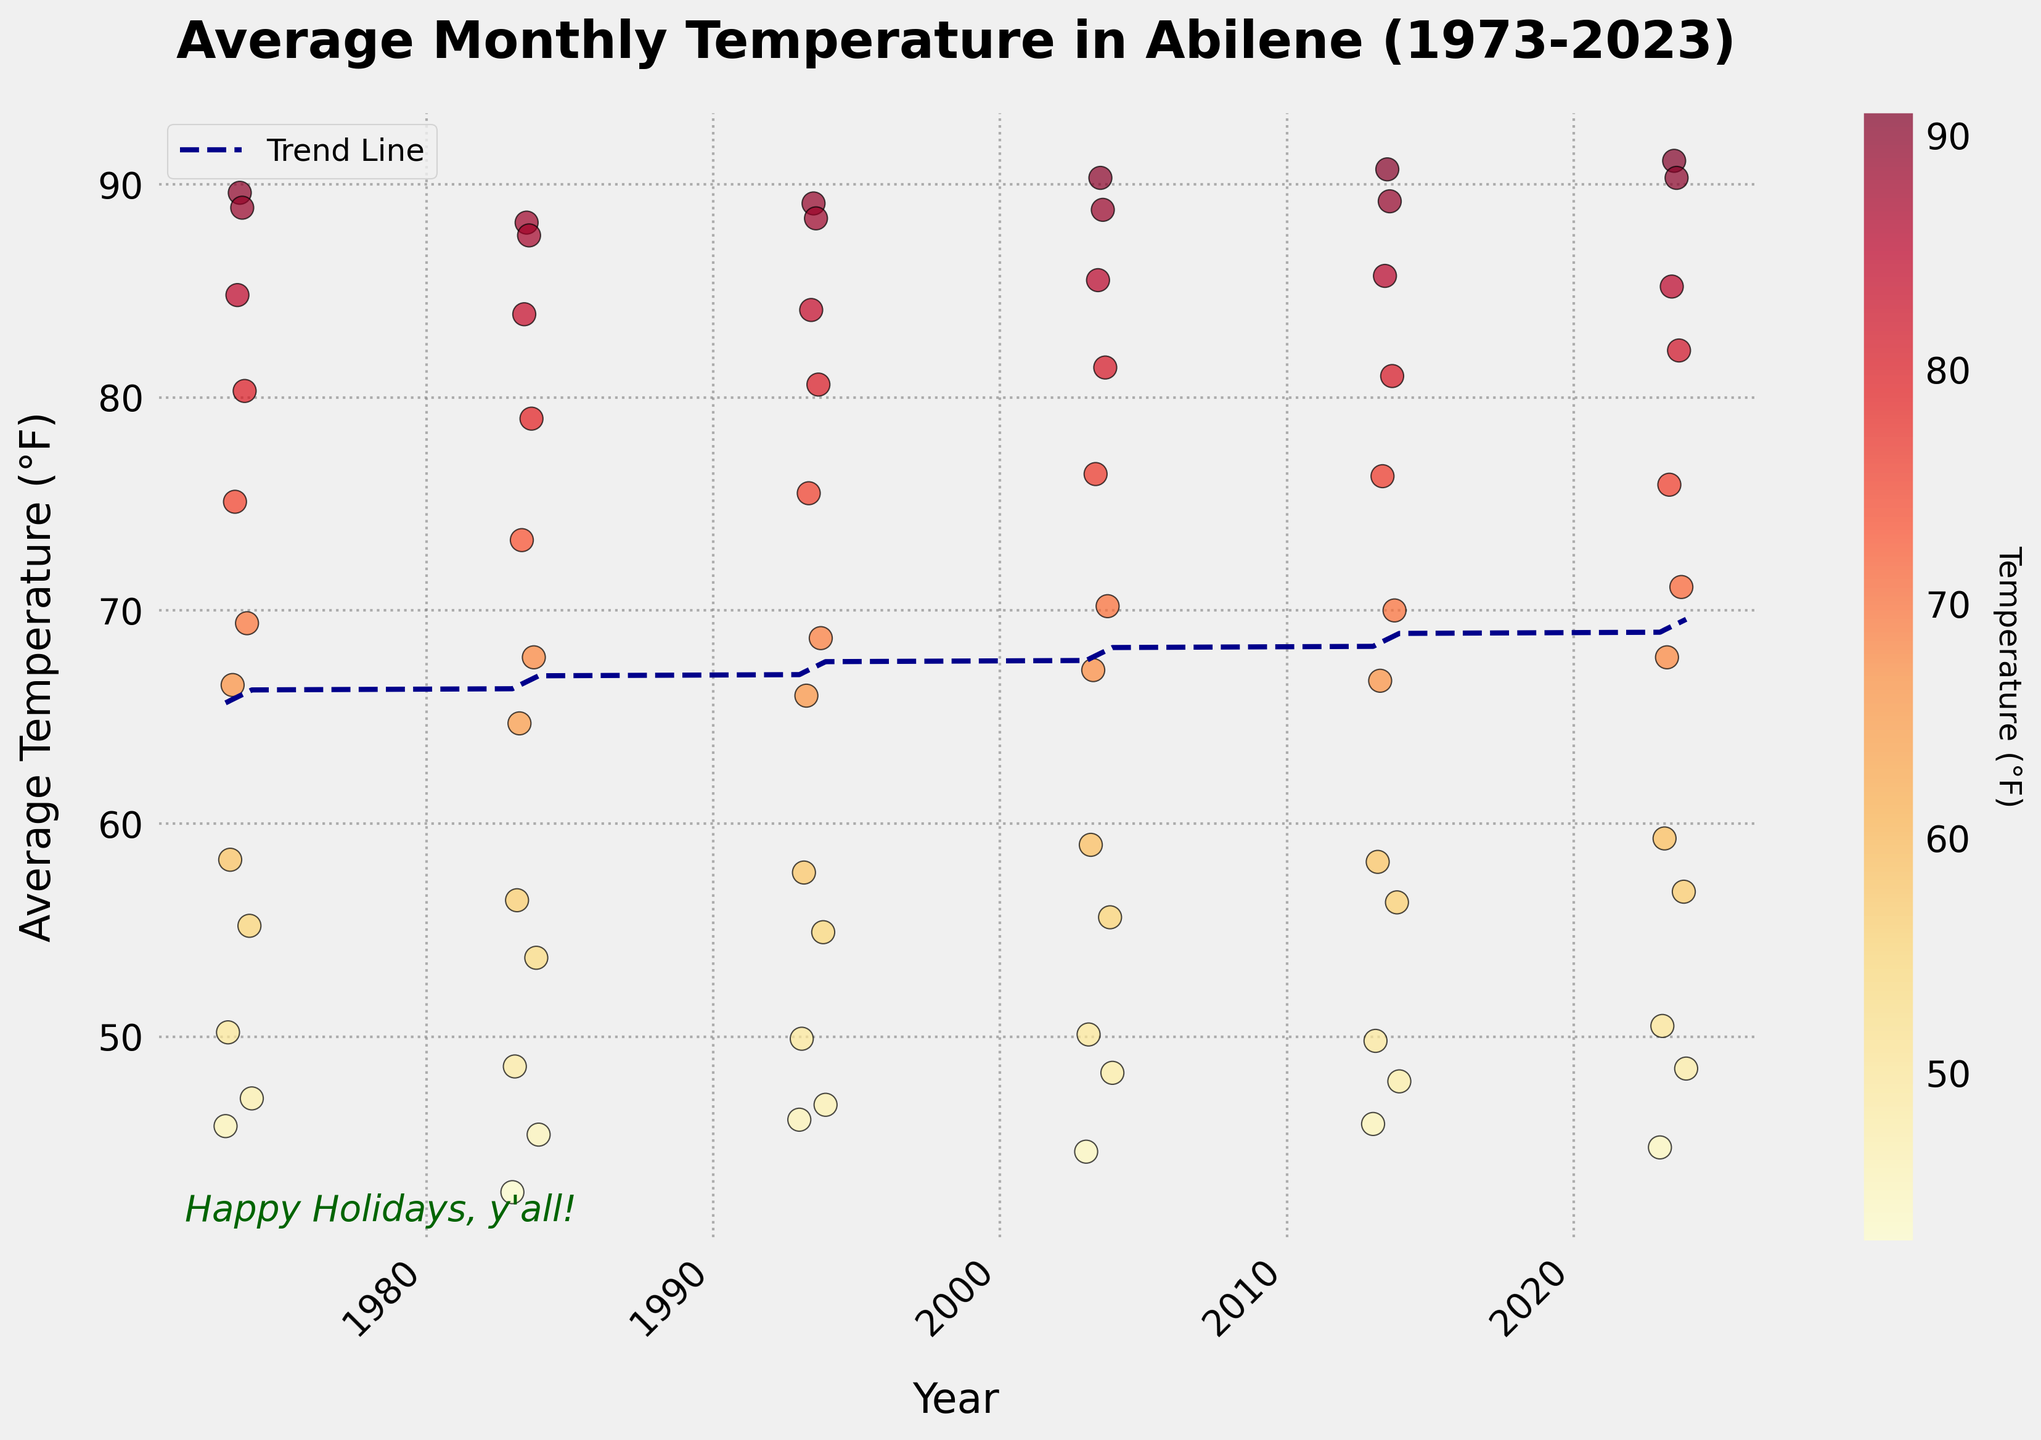What's the title of the plot? The title is located at the top of the plot, and it clearly states the subject.
Answer: "Average Monthly Temperature in Abilene (1973-2023)" How is the trend line shown in the plot? The trend line is represented using a red dashed line that helps in visualizing the overall trend in the data points.
Answer: Red dashed line What is the average temperature in July 2023? Locate the data point for July 2023 along the x-axis. The accompanying y-value gives the average temperature for that month.
Answer: 91.1°F Which month has the highest average temperature in 2003? Identify the data points for the year 2003. Among those, find the month with the highest y-value.
Answer: July Does the plot show temperatures increasing or decreasing over the years? Examine the direction of the trend line: an upward slope indicates an increase and a downward slope indicates a decrease.
Answer: Increasing How does the December 1973 temperature compare to the December 1983 temperature? Locate the December temperatures for both years. Compare their y-values to see which is higher.
Answer: December 1973 (47.1°F) is higher than December 1983 (45.4°F) Which year recorded the coldest January temperature, and what was it? Identify the January temperatures for each year and find the minimum value.
Answer: 1983, 42.7°F Is the average August temperature in 2023 higher or lower than in 2013? Compare the y-values for August in both 2023 and 2013.
Answer: Higher in 2023 (90.3°F) compared to 2013 (89.2°F) What is the general trend of average temperatures in the month of May over the 50 years? Examine the cluster of data points for May across all the years and observe their trend relative to the y-axis.
Answer: Increasing How many distinct years of data points are represented in the plot? Count the number of unique years along the x-axis from the scatter points.
Answer: 6 